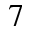Convert formula to latex. <formula><loc_0><loc_0><loc_500><loc_500>_ { 7 }</formula> 